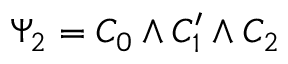Convert formula to latex. <formula><loc_0><loc_0><loc_500><loc_500>\Psi _ { 2 } = C _ { 0 } \wedge C _ { 1 } ^ { \prime } \wedge C _ { 2 }</formula> 